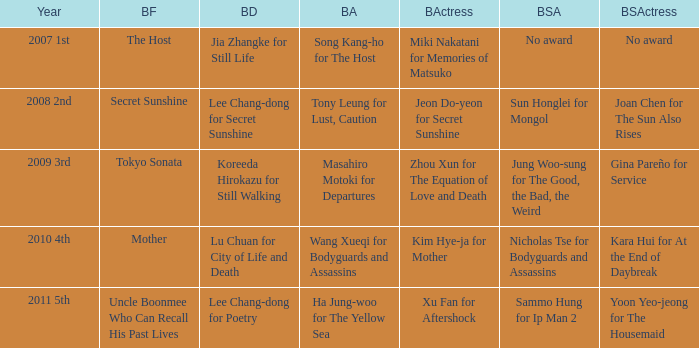Specify the year sammo hung was in ip man 2011 5th. 